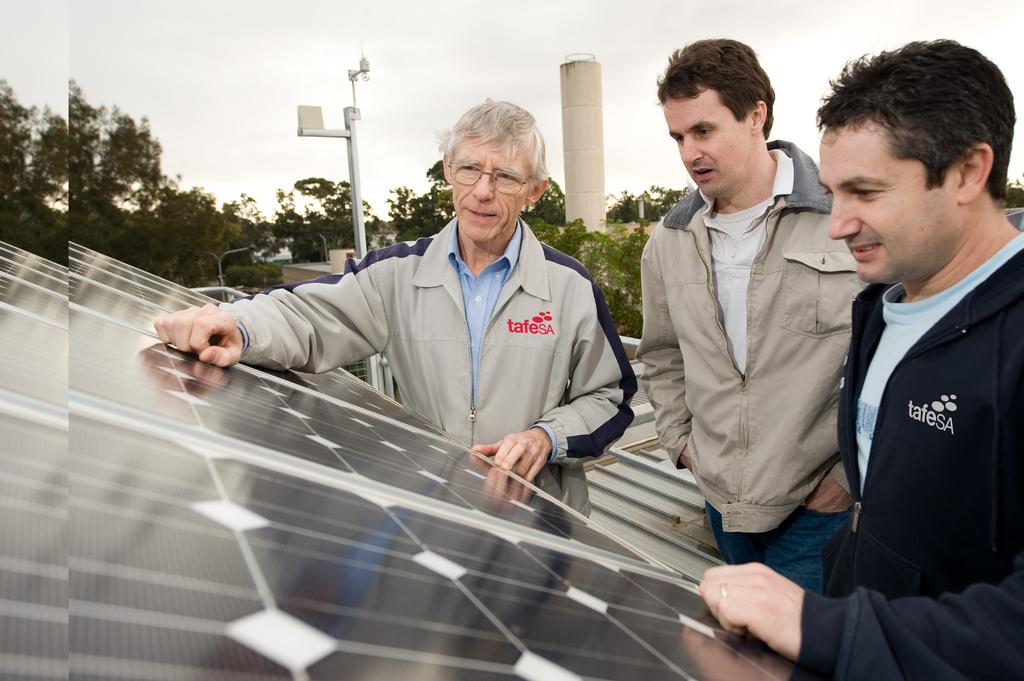What can be seen in the image? There are men standing in the image, along with solar panels, a street light pole, a tower building, and trees visible in the background. What is the condition of the sky in the image? The sky is clear in the image. What color is the vest worn by the man in the image? There is no mention of a vest being worn by any of the men in the image. Is there a van visible in the image? No, there is no van present in the image. Can you see any smoke coming from the solar panels in the image? No, there is no smoke visible in the image. 